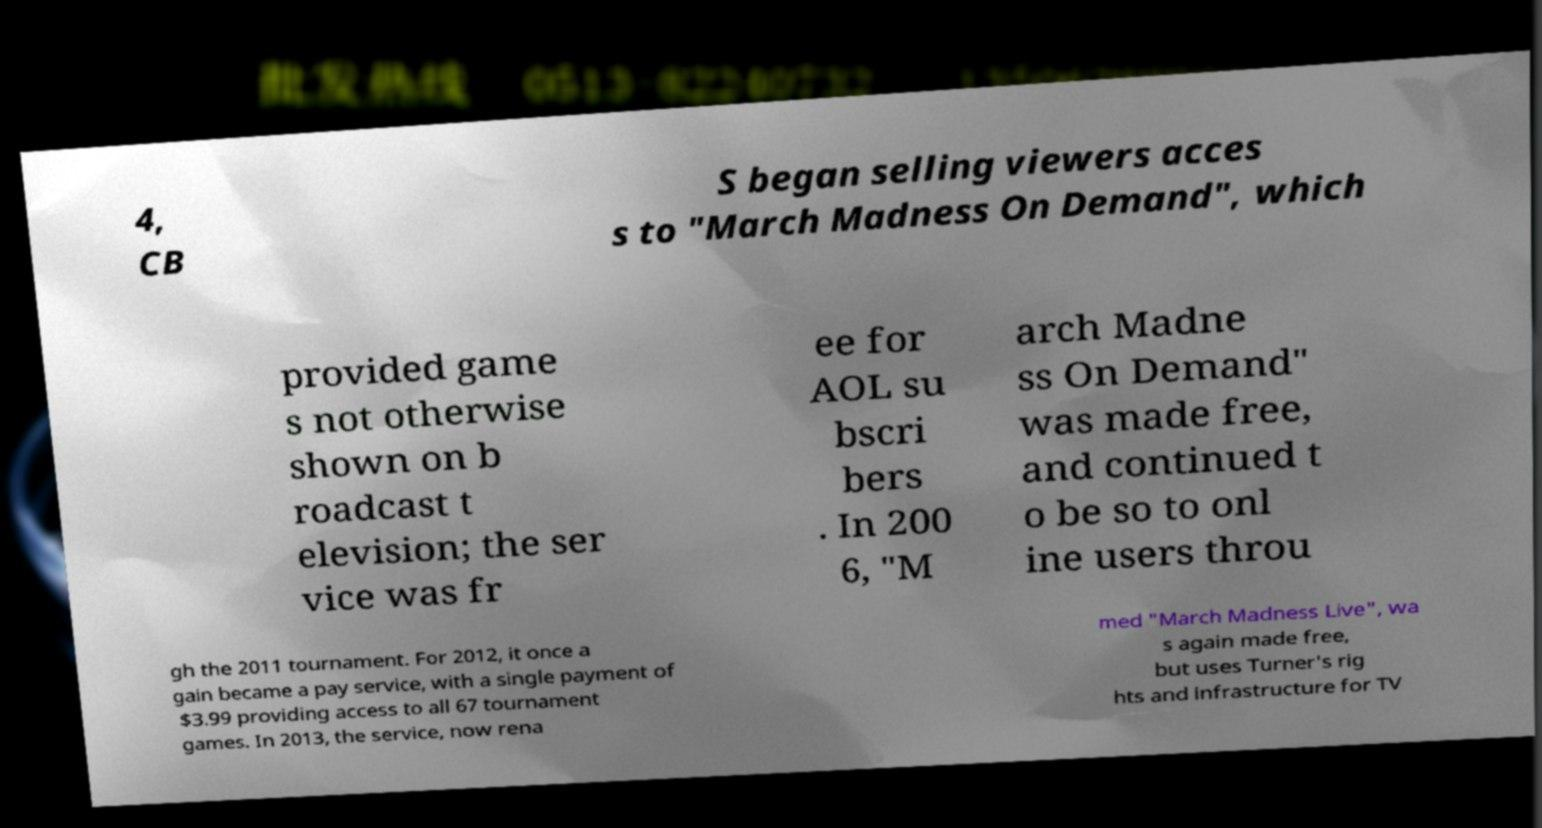What messages or text are displayed in this image? I need them in a readable, typed format. 4, CB S began selling viewers acces s to "March Madness On Demand", which provided game s not otherwise shown on b roadcast t elevision; the ser vice was fr ee for AOL su bscri bers . In 200 6, "M arch Madne ss On Demand" was made free, and continued t o be so to onl ine users throu gh the 2011 tournament. For 2012, it once a gain became a pay service, with a single payment of $3.99 providing access to all 67 tournament games. In 2013, the service, now rena med "March Madness Live", wa s again made free, but uses Turner's rig hts and infrastructure for TV 